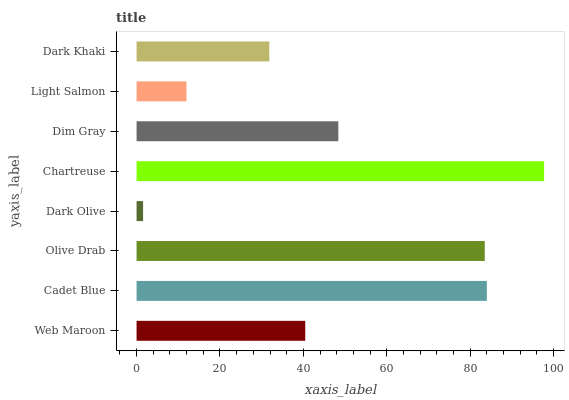Is Dark Olive the minimum?
Answer yes or no. Yes. Is Chartreuse the maximum?
Answer yes or no. Yes. Is Cadet Blue the minimum?
Answer yes or no. No. Is Cadet Blue the maximum?
Answer yes or no. No. Is Cadet Blue greater than Web Maroon?
Answer yes or no. Yes. Is Web Maroon less than Cadet Blue?
Answer yes or no. Yes. Is Web Maroon greater than Cadet Blue?
Answer yes or no. No. Is Cadet Blue less than Web Maroon?
Answer yes or no. No. Is Dim Gray the high median?
Answer yes or no. Yes. Is Web Maroon the low median?
Answer yes or no. Yes. Is Dark Olive the high median?
Answer yes or no. No. Is Dark Khaki the low median?
Answer yes or no. No. 